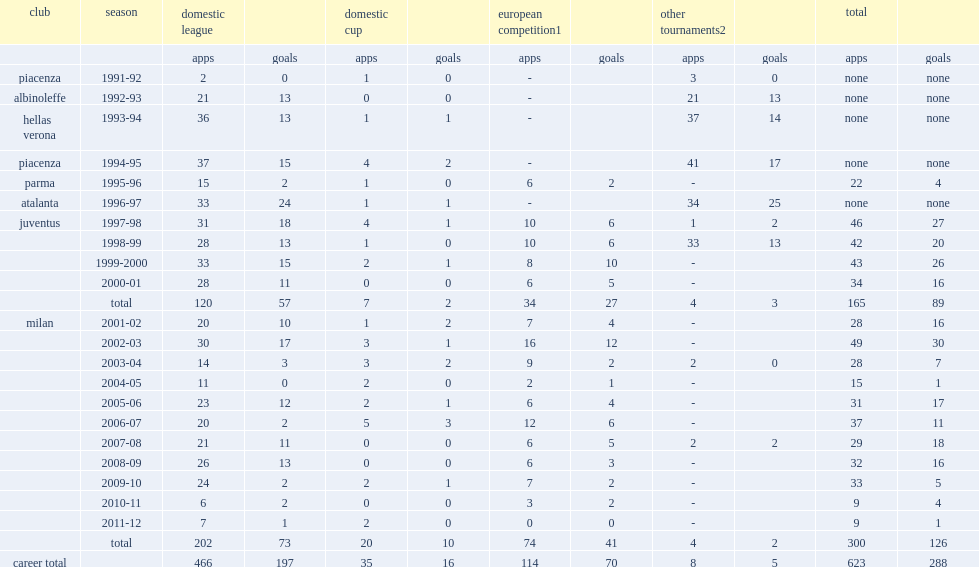How many goals did filippo inzaghi score for juventus totally? 89.0. 